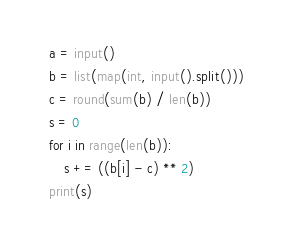Convert code to text. <code><loc_0><loc_0><loc_500><loc_500><_Python_>a = input()
b = list(map(int, input().split()))
c = round(sum(b) / len(b))
s = 0
for i in range(len(b)):
    s += ((b[i] - c) ** 2)
print(s)</code> 